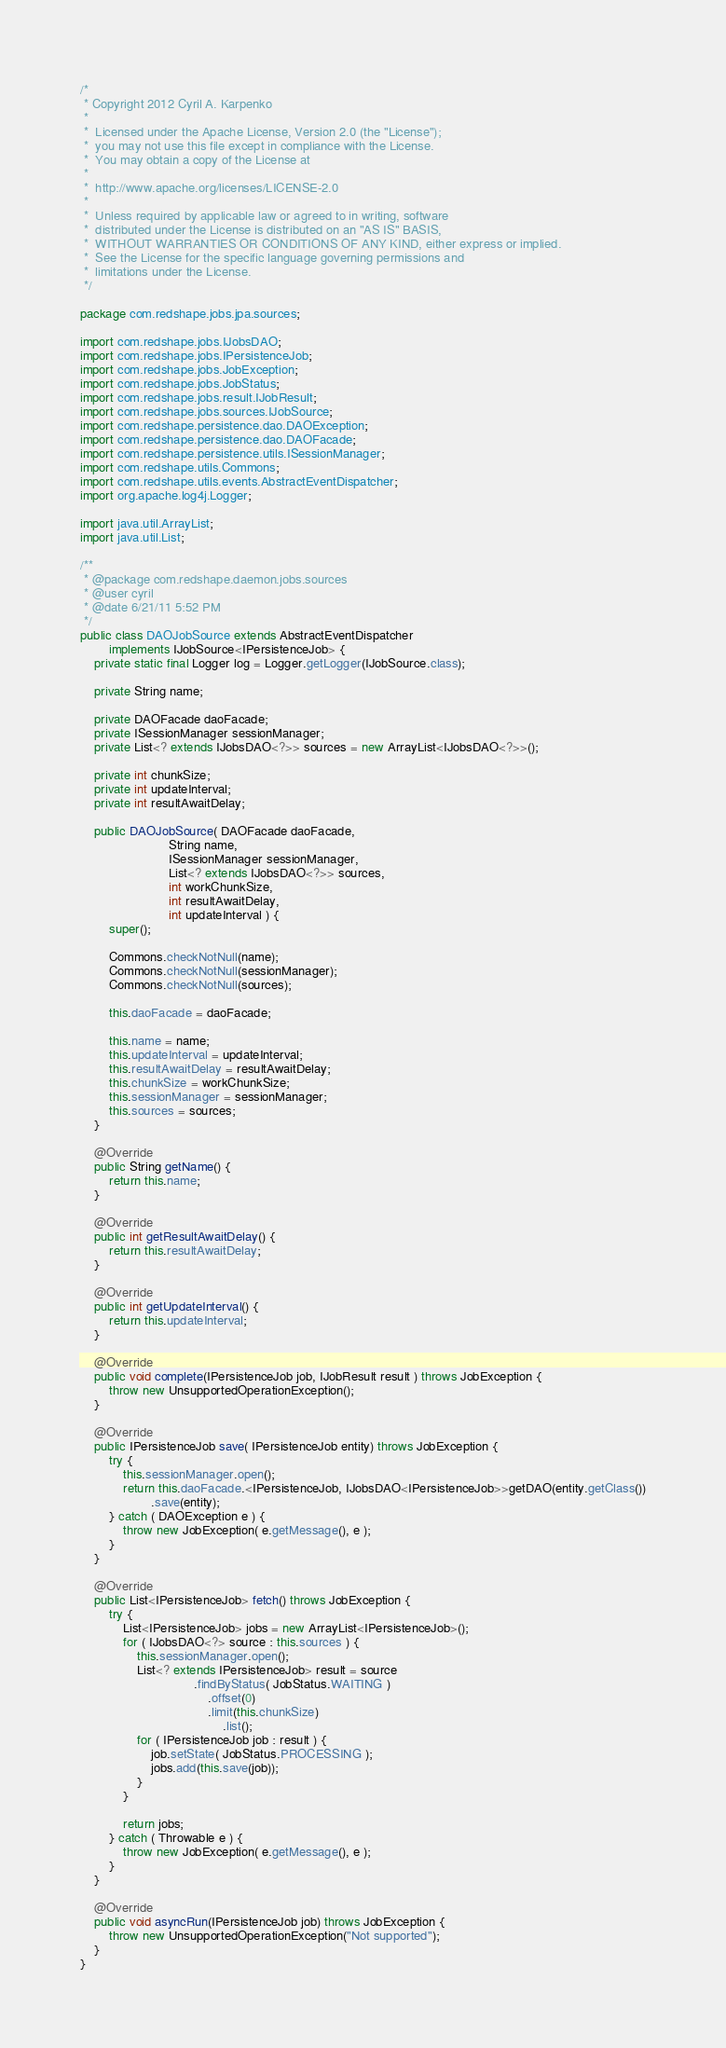<code> <loc_0><loc_0><loc_500><loc_500><_Java_>/*
 * Copyright 2012 Cyril A. Karpenko
 *
 *  Licensed under the Apache License, Version 2.0 (the "License");
 *  you may not use this file except in compliance with the License.
 *  You may obtain a copy of the License at
 *
 *  http://www.apache.org/licenses/LICENSE-2.0
 *
 *  Unless required by applicable law or agreed to in writing, software
 *  distributed under the License is distributed on an "AS IS" BASIS,
 *  WITHOUT WARRANTIES OR CONDITIONS OF ANY KIND, either express or implied.
 *  See the License for the specific language governing permissions and
 *  limitations under the License.
 */

package com.redshape.jobs.jpa.sources;

import com.redshape.jobs.IJobsDAO;
import com.redshape.jobs.IPersistenceJob;
import com.redshape.jobs.JobException;
import com.redshape.jobs.JobStatus;
import com.redshape.jobs.result.IJobResult;
import com.redshape.jobs.sources.IJobSource;
import com.redshape.persistence.dao.DAOException;
import com.redshape.persistence.dao.DAOFacade;
import com.redshape.persistence.utils.ISessionManager;
import com.redshape.utils.Commons;
import com.redshape.utils.events.AbstractEventDispatcher;
import org.apache.log4j.Logger;

import java.util.ArrayList;
import java.util.List;

/**
 * @package com.redshape.daemon.jobs.sources
 * @user cyril
 * @date 6/21/11 5:52 PM
 */
public class DAOJobSource extends AbstractEventDispatcher
        implements IJobSource<IPersistenceJob> {
    private static final Logger log = Logger.getLogger(IJobSource.class);

    private String name;

    private DAOFacade daoFacade;
    private ISessionManager sessionManager;
    private List<? extends IJobsDAO<?>> sources = new ArrayList<IJobsDAO<?>>();

    private int chunkSize;
    private int updateInterval;
    private int resultAwaitDelay;

    public DAOJobSource( DAOFacade daoFacade,
                         String name,
                         ISessionManager sessionManager,
                         List<? extends IJobsDAO<?>> sources,
                         int workChunkSize,
                         int resultAwaitDelay,
                         int updateInterval ) {
        super();

        Commons.checkNotNull(name);
        Commons.checkNotNull(sessionManager);
        Commons.checkNotNull(sources);

        this.daoFacade = daoFacade;

        this.name = name;
        this.updateInterval = updateInterval;
        this.resultAwaitDelay = resultAwaitDelay;
        this.chunkSize = workChunkSize;
        this.sessionManager = sessionManager;
        this.sources = sources;
    }

    @Override
    public String getName() {
        return this.name;
    }

    @Override
    public int getResultAwaitDelay() {
        return this.resultAwaitDelay;
    }

    @Override
    public int getUpdateInterval() {
        return this.updateInterval;
    }

    @Override
    public void complete(IPersistenceJob job, IJobResult result ) throws JobException {
        throw new UnsupportedOperationException();
    }

    @Override
    public IPersistenceJob save( IPersistenceJob entity) throws JobException {
        try {
			this.sessionManager.open();
            return this.daoFacade.<IPersistenceJob, IJobsDAO<IPersistenceJob>>getDAO(entity.getClass())
                    .save(entity);
        } catch ( DAOException e ) {
            throw new JobException( e.getMessage(), e );
        }
    }

    @Override
    public List<IPersistenceJob> fetch() throws JobException {
		try {
            List<IPersistenceJob> jobs = new ArrayList<IPersistenceJob>();
            for ( IJobsDAO<?> source : this.sources ) {
                this.sessionManager.open();
                List<? extends IPersistenceJob> result = source
                                .findByStatus( JobStatus.WAITING )
                                    .offset(0)
                                    .limit(this.chunkSize)
                                        .list();
                for ( IPersistenceJob job : result ) {
                    job.setState( JobStatus.PROCESSING );
                    jobs.add(this.save(job));
                }
            }

            return jobs;
        } catch ( Throwable e ) {
            throw new JobException( e.getMessage(), e );
        }
    }

    @Override
    public void asyncRun(IPersistenceJob job) throws JobException {
        throw new UnsupportedOperationException("Not supported");
    }
}
</code> 